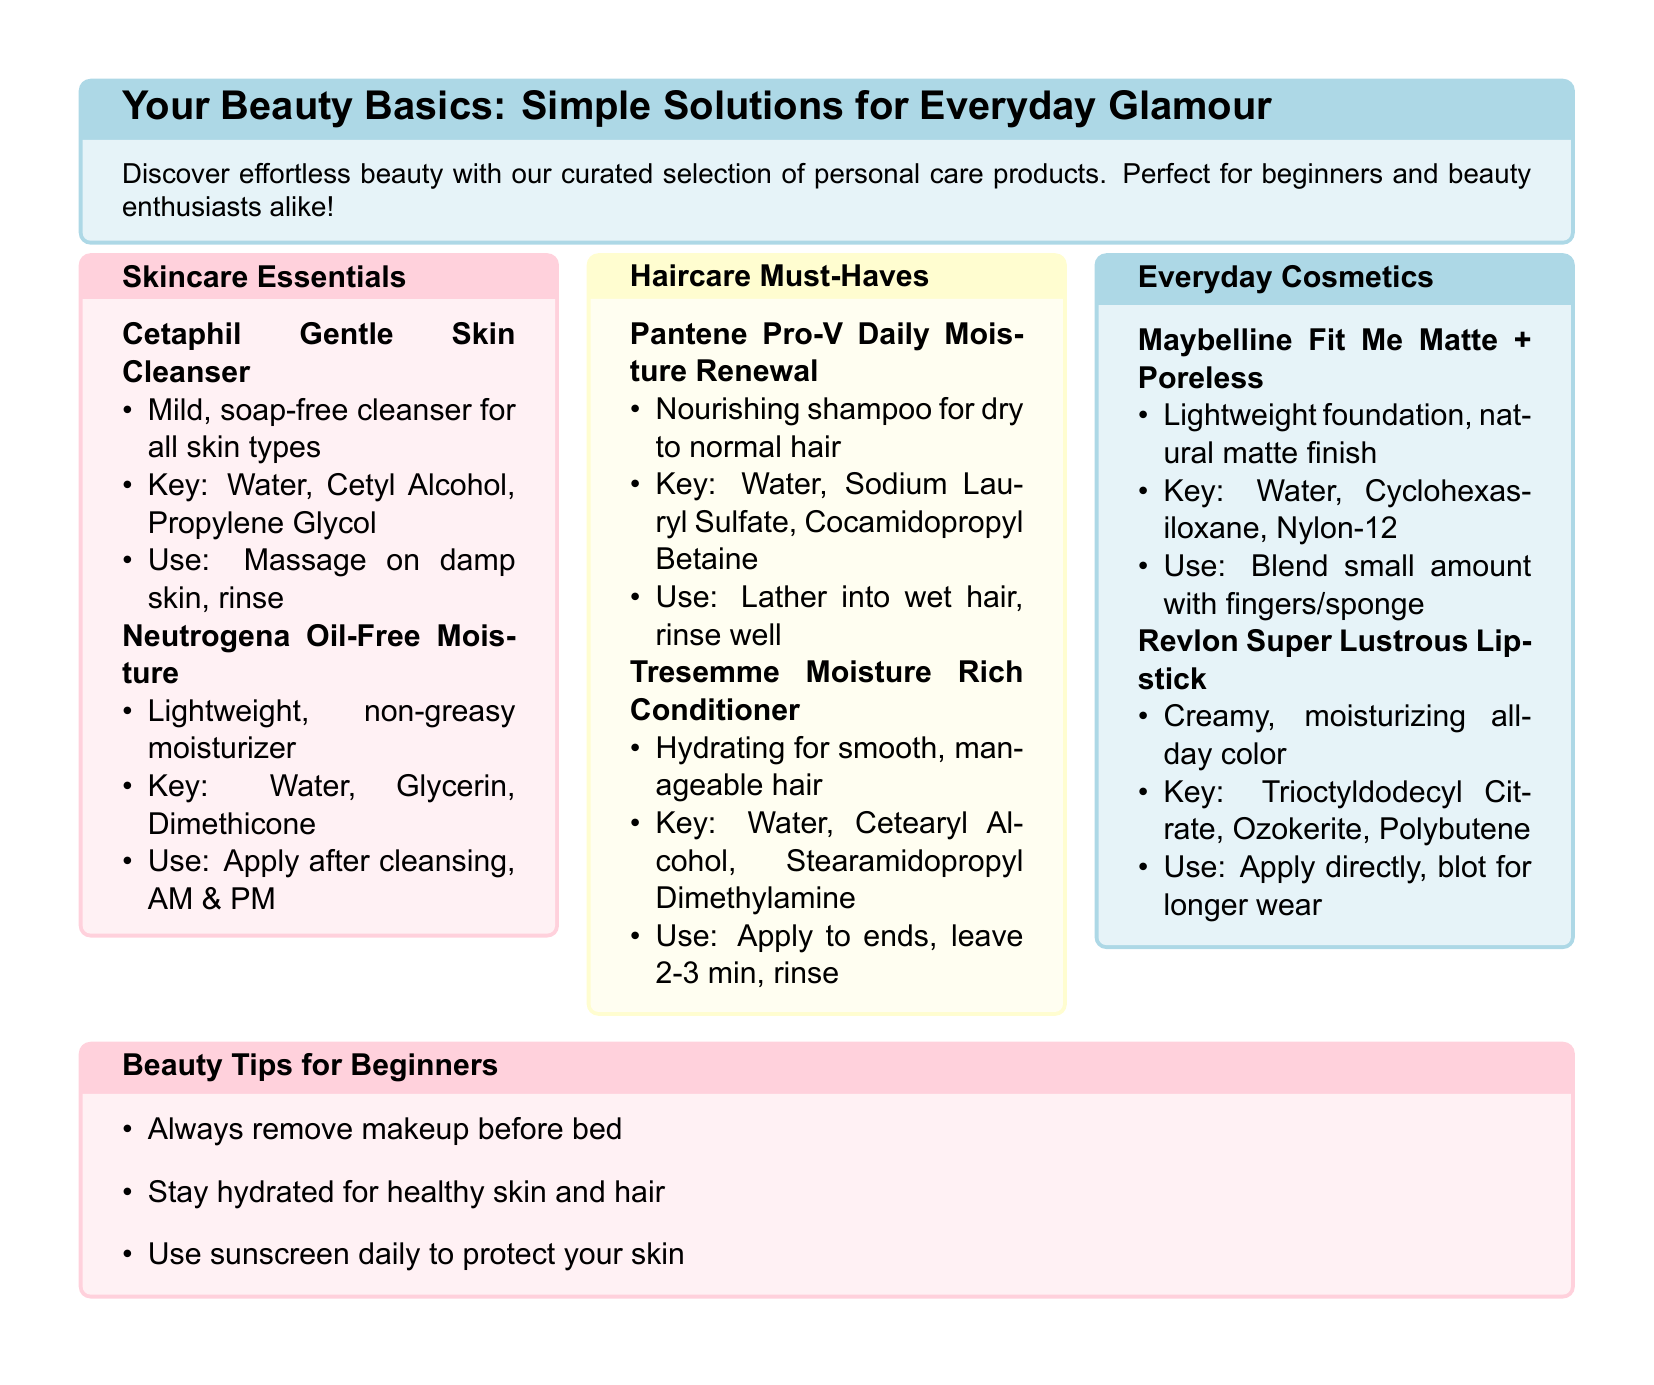What is the primary function of Cetaphil Gentle Skin Cleanser? The primary function is to serve as a mild, soap-free cleanser for all skin types.
Answer: Mild, soap-free cleanser What key ingredient is found in Neutrogena Oil-Free Moisture? One of the key ingredients in this product is Glycerin.
Answer: Glycerin How long should Tresemme Moisture Rich Conditioner be left in the hair before rinsing? The conditioner should be left in for 2-3 minutes before rinsing.
Answer: 2-3 minutes What type of finish does Maybelline Fit Me Matte + Poreless provide? It provides a natural matte finish.
Answer: Natural matte finish What is a beauty tip mentioned for beginners? One tip is to always remove makeup before bed.
Answer: Always remove makeup before bed Which product is recommended for dry to normal hair? Pantene Pro-V Daily Moisture Renewal is recommended for dry to normal hair.
Answer: Pantene Pro-V Daily Moisture Renewal What should you apply after cleansing according to the guidelines for Neutrogena Oil-Free Moisture? You should apply it after cleansing.
Answer: After cleansing What color is the packaging of the Everyday Cosmetics section? The packaging color of the Everyday Cosmetics section is pastel blue.
Answer: Pastel blue 